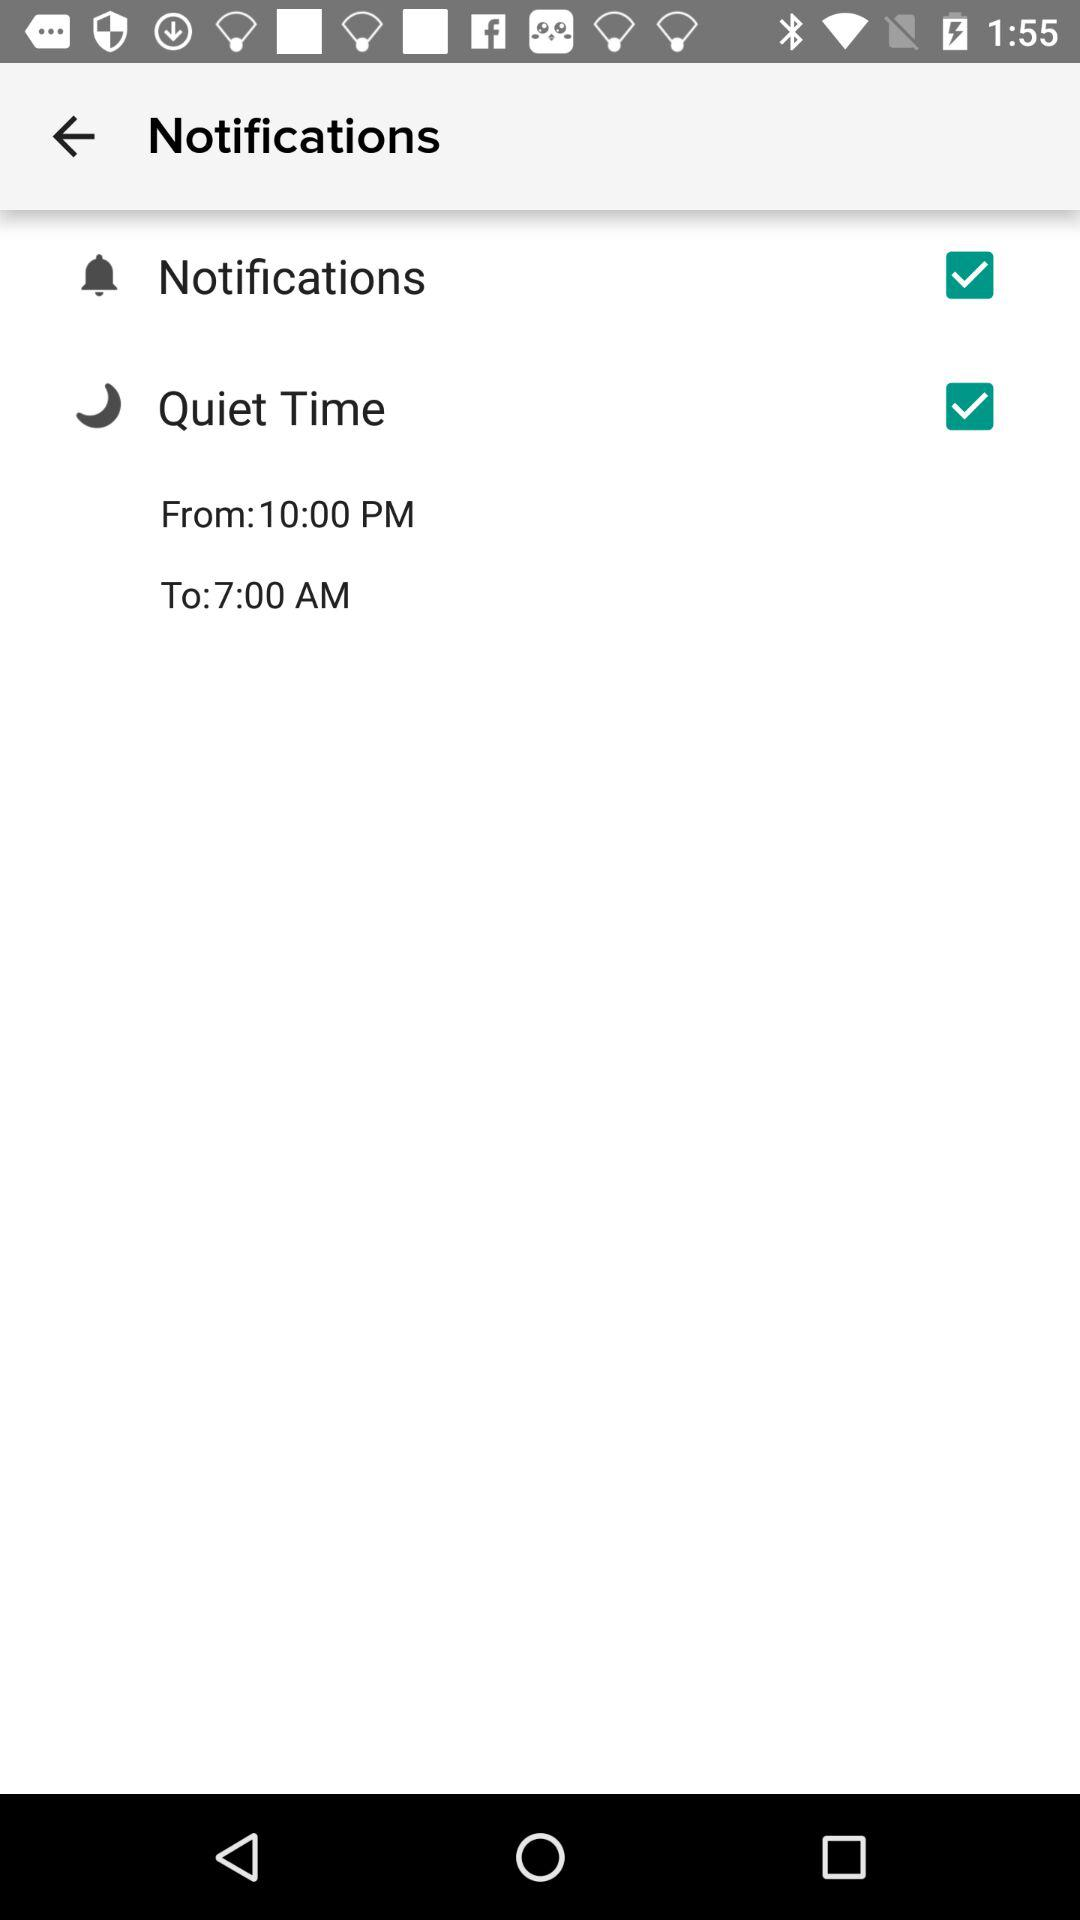What is the status of the "Quiet Time"? The status of the "Quiet Time" is "on". 